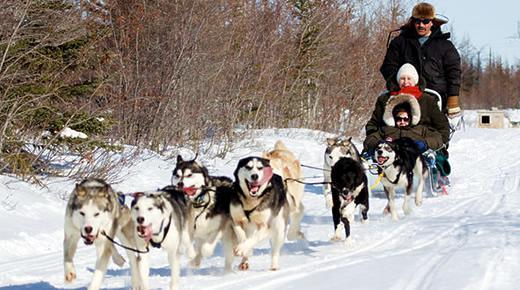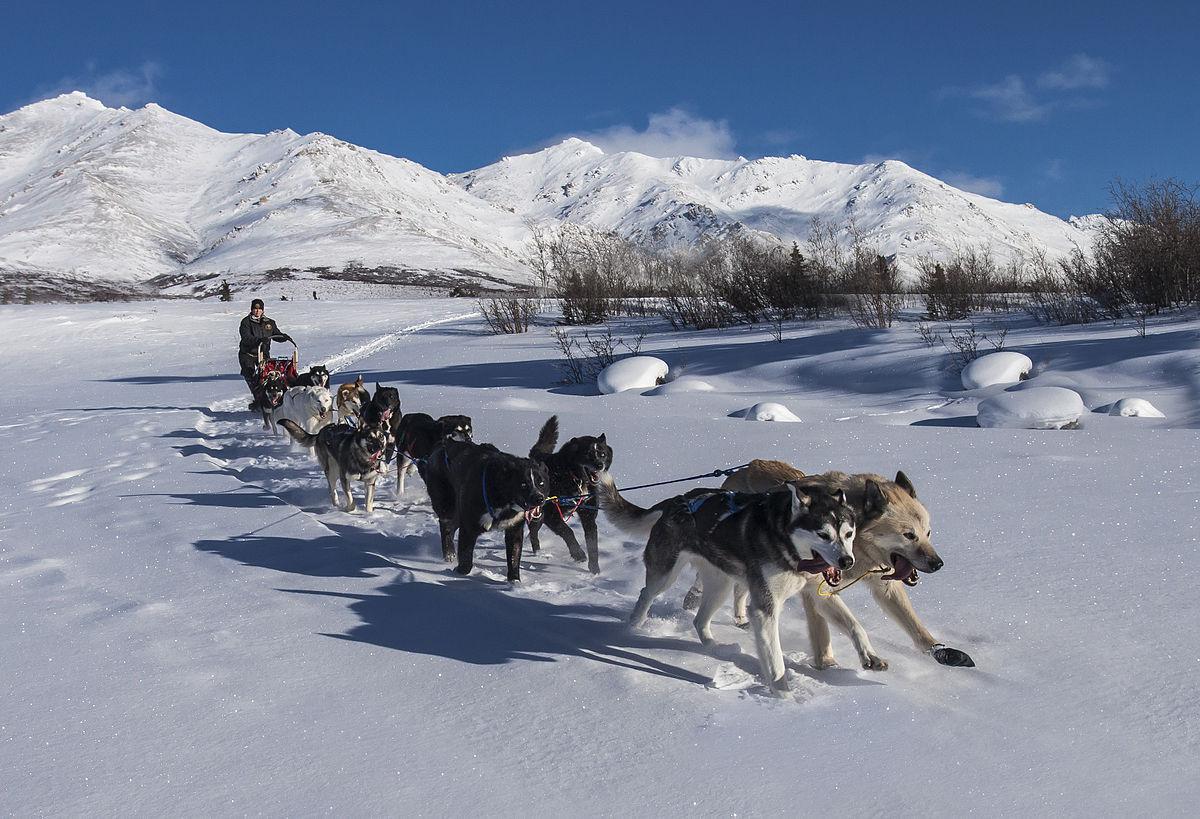The first image is the image on the left, the second image is the image on the right. Assess this claim about the two images: "At least one of the images features six or less dogs pulling a sled.". Correct or not? Answer yes or no. No. The first image is the image on the left, the second image is the image on the right. Examine the images to the left and right. Is the description "Right image shows a sled dog team with a mountain range behind them." accurate? Answer yes or no. Yes. 